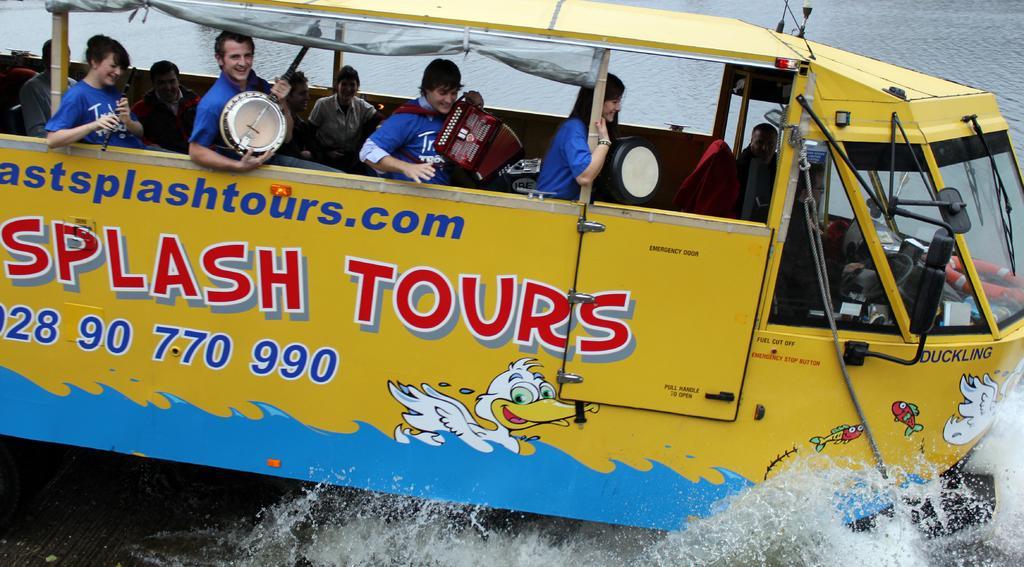Describe this image in one or two sentences. In this image I can see the vehicle which is in yellow color. I can see something is written on it. There are few people sitting on the vehicle and these people are holding the musical instruments. In the background I can see the water. 